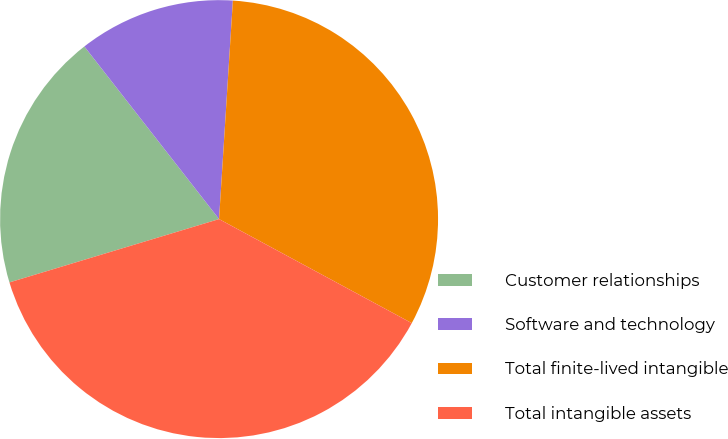Convert chart. <chart><loc_0><loc_0><loc_500><loc_500><pie_chart><fcel>Customer relationships<fcel>Software and technology<fcel>Total finite-lived intangible<fcel>Total intangible assets<nl><fcel>19.12%<fcel>11.55%<fcel>31.87%<fcel>37.45%<nl></chart> 